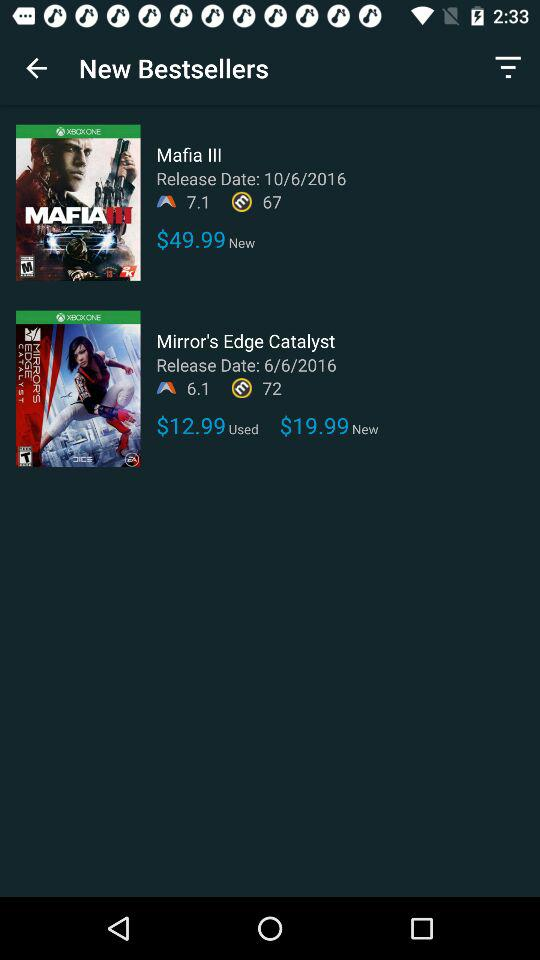What is the price of "Mafia III"? The price of "Mafia III" is $49.99. 